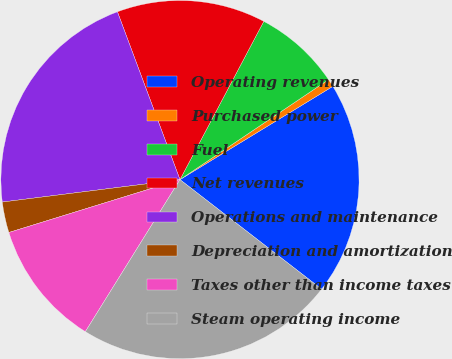<chart> <loc_0><loc_0><loc_500><loc_500><pie_chart><fcel>Operating revenues<fcel>Purchased power<fcel>Fuel<fcel>Net revenues<fcel>Operations and maintenance<fcel>Depreciation and amortization<fcel>Taxes other than income taxes<fcel>Steam operating income<nl><fcel>19.19%<fcel>0.71%<fcel>7.82%<fcel>13.43%<fcel>21.32%<fcel>2.77%<fcel>11.37%<fcel>23.38%<nl></chart> 